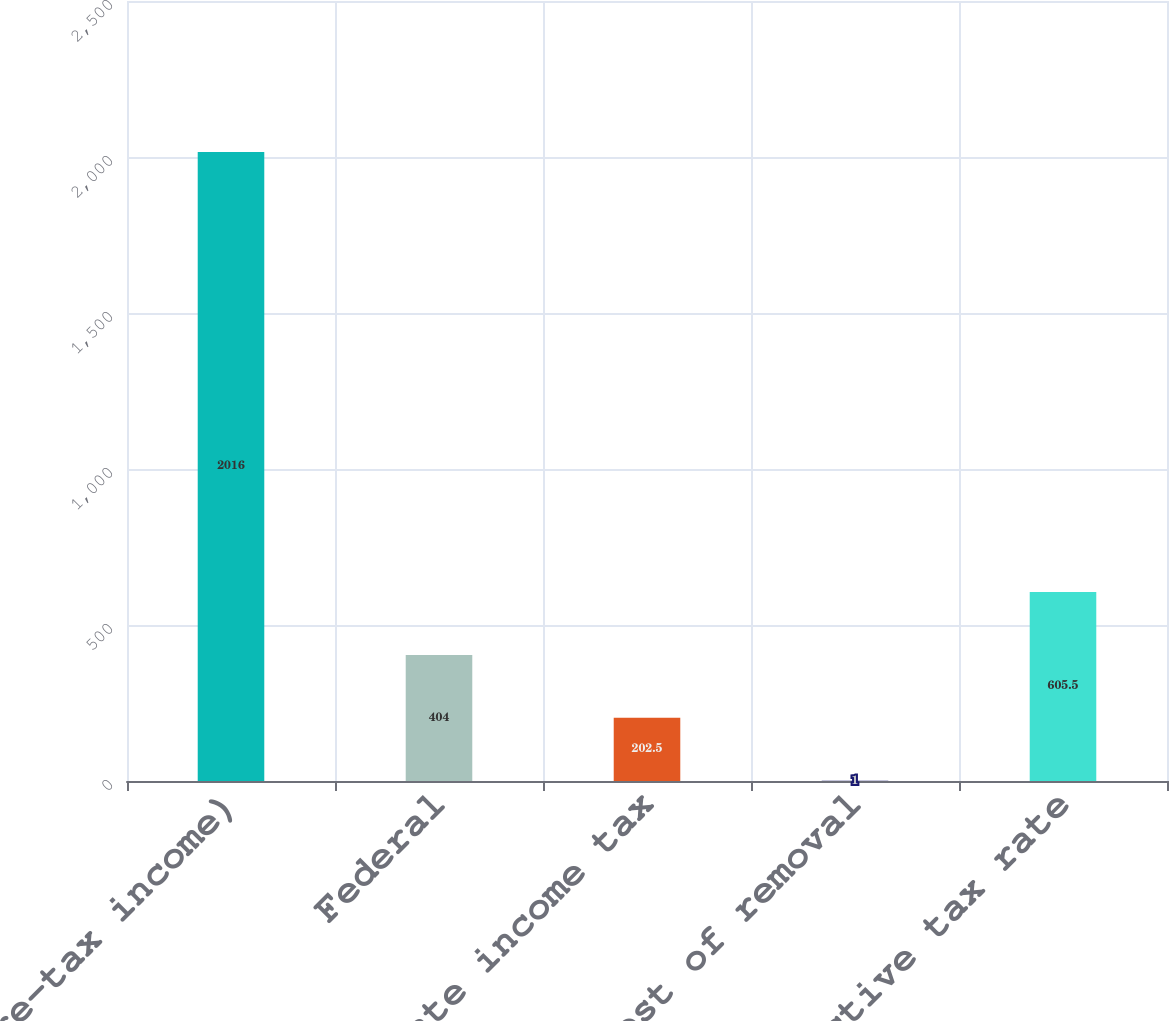Convert chart. <chart><loc_0><loc_0><loc_500><loc_500><bar_chart><fcel>( of Pre-tax income)<fcel>Federal<fcel>State income tax<fcel>Cost of removal<fcel>Effective tax rate<nl><fcel>2016<fcel>404<fcel>202.5<fcel>1<fcel>605.5<nl></chart> 